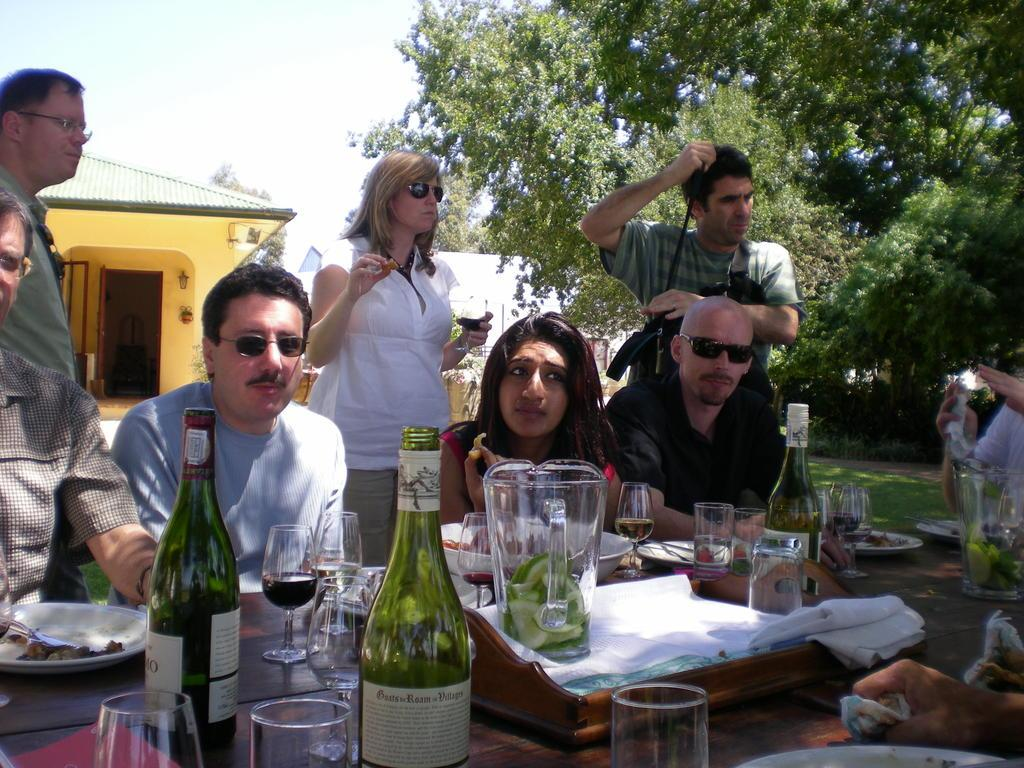What is on the table in the image? There is a glass, a bottle, food, a plate, and a bowl on the table. What might be used for drinking in the image? The glass on the table might be used for drinking. What might be used for holding a beverage in the image? The bottle on the table might be used for holding a beverage. What might be used for serving food in the image? The plate and bowl on the table might be used for serving food. What is the setting of the image? The image shows people sitting and standing near a table, with a house and trees in the background. Is there any quicksand visible in the image? No, there is no quicksand present in the image. What type of toothpaste is being used by the people in the image? There is no toothpaste visible in the image. 